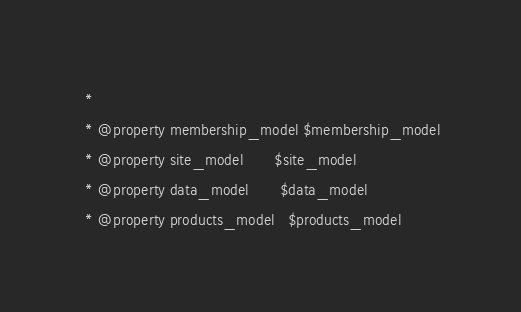<code> <loc_0><loc_0><loc_500><loc_500><_PHP_> *
 * @property membership_model $membership_model
 * @property site_model       $site_model
 * @property data_model       $data_model
 * @property products_model   $products_model</code> 